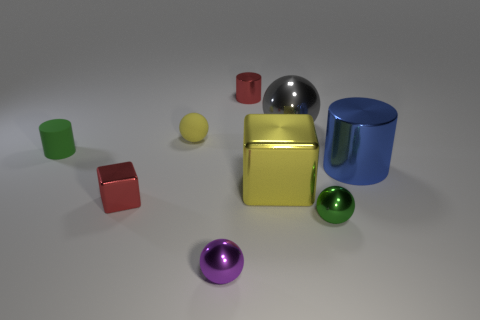Subtract all metallic cylinders. How many cylinders are left? 1 Subtract 1 cylinders. How many cylinders are left? 2 Add 1 big rubber blocks. How many objects exist? 10 Subtract all red balls. Subtract all gray cylinders. How many balls are left? 4 Subtract all tiny brown metal spheres. Subtract all purple metal spheres. How many objects are left? 8 Add 7 shiny spheres. How many shiny spheres are left? 10 Add 5 large blue metal objects. How many large blue metal objects exist? 6 Subtract 0 gray cylinders. How many objects are left? 9 Subtract all cylinders. How many objects are left? 6 